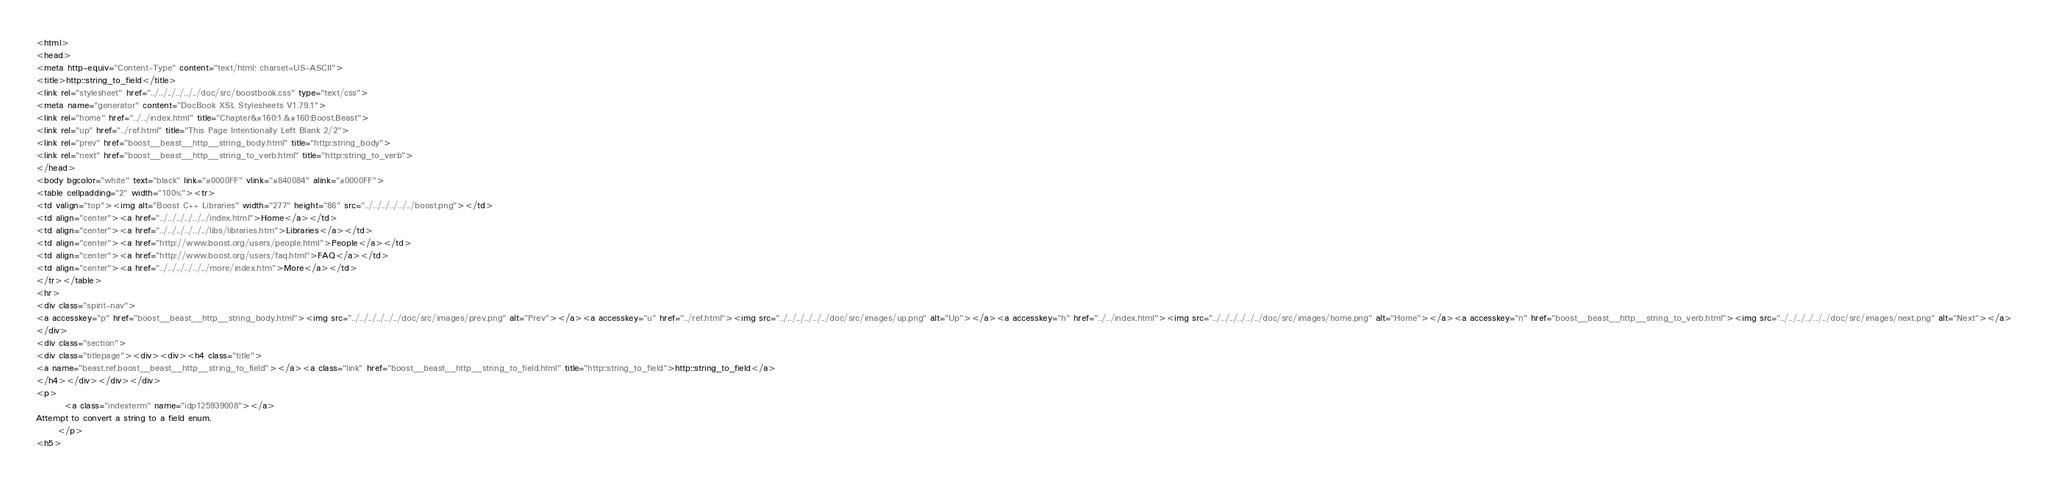<code> <loc_0><loc_0><loc_500><loc_500><_HTML_><html>
<head>
<meta http-equiv="Content-Type" content="text/html; charset=US-ASCII">
<title>http::string_to_field</title>
<link rel="stylesheet" href="../../../../../../doc/src/boostbook.css" type="text/css">
<meta name="generator" content="DocBook XSL Stylesheets V1.79.1">
<link rel="home" href="../../index.html" title="Chapter&#160;1.&#160;Boost.Beast">
<link rel="up" href="../ref.html" title="This Page Intentionally Left Blank 2/2">
<link rel="prev" href="boost__beast__http__string_body.html" title="http::string_body">
<link rel="next" href="boost__beast__http__string_to_verb.html" title="http::string_to_verb">
</head>
<body bgcolor="white" text="black" link="#0000FF" vlink="#840084" alink="#0000FF">
<table cellpadding="2" width="100%"><tr>
<td valign="top"><img alt="Boost C++ Libraries" width="277" height="86" src="../../../../../../boost.png"></td>
<td align="center"><a href="../../../../../../index.html">Home</a></td>
<td align="center"><a href="../../../../../../libs/libraries.htm">Libraries</a></td>
<td align="center"><a href="http://www.boost.org/users/people.html">People</a></td>
<td align="center"><a href="http://www.boost.org/users/faq.html">FAQ</a></td>
<td align="center"><a href="../../../../../../more/index.htm">More</a></td>
</tr></table>
<hr>
<div class="spirit-nav">
<a accesskey="p" href="boost__beast__http__string_body.html"><img src="../../../../../../doc/src/images/prev.png" alt="Prev"></a><a accesskey="u" href="../ref.html"><img src="../../../../../../doc/src/images/up.png" alt="Up"></a><a accesskey="h" href="../../index.html"><img src="../../../../../../doc/src/images/home.png" alt="Home"></a><a accesskey="n" href="boost__beast__http__string_to_verb.html"><img src="../../../../../../doc/src/images/next.png" alt="Next"></a>
</div>
<div class="section">
<div class="titlepage"><div><div><h4 class="title">
<a name="beast.ref.boost__beast__http__string_to_field"></a><a class="link" href="boost__beast__http__string_to_field.html" title="http::string_to_field">http::string_to_field</a>
</h4></div></div></div>
<p>
        <a class="indexterm" name="idp125939008"></a>
Attempt to convert a string to a field enum.
      </p>
<h5></code> 